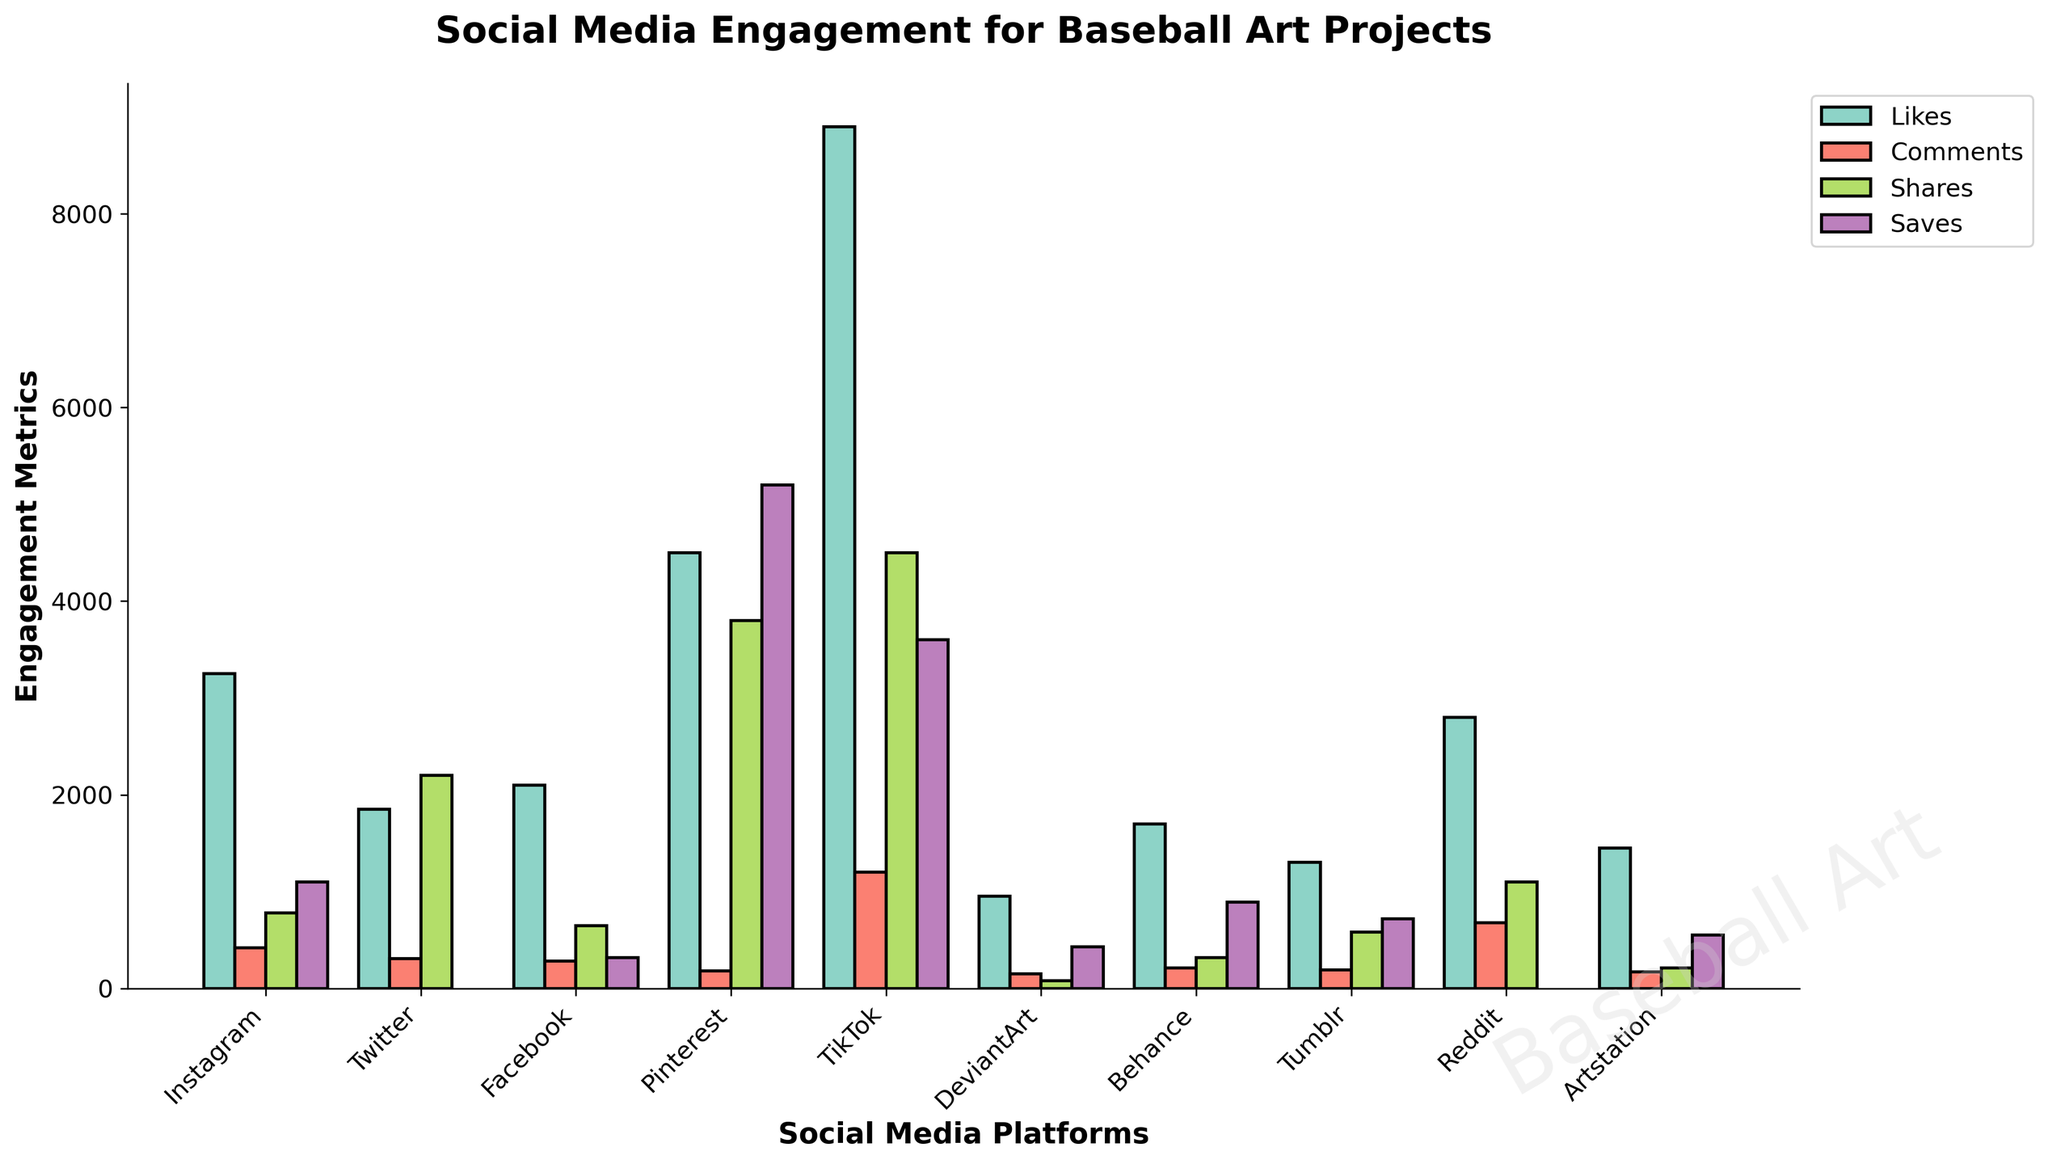Which platform has the highest number of likes? To find the platform with the highest number of likes, observe the bar heights in the "Likes" category. TikTok has the tallest bar in this category.
Answer: TikTok Which platform has the lowest comments compared to all others? Check the bar heights in the "Comments" category. Pinterest has the shortest bar.
Answer: Pinterest How many total shares are there for DeviantArt and Reddit combined? DeviantArt has 80 shares and Reddit has 1100 shares. Summing them up gives 80 + 1100.
Answer: 1180 Does any platform have fewer saves than DeviantArt? DeviantArt has 430 saves. Observe all platforms in the "Saves" category to see if there's any with fewer. No other platform has fewer saves than 430.
Answer: No Which platform has the second highest number of shares, and how does it compare to the highest one? TikTok has the highest number of shares. To find the second highest, compare the rest after TikTok. Pinterest comes second. TikTok has 4500 shares and Pinterest has 3800 shares, so 4500 - 3800 = 700.
Answer: Pinterest, 700 less What is the average number of comments across all platforms? Sum the comments for all platforms: 420 + 310 + 280 + 180 + 1200 + 150 + 210 + 190 + 680 + 170 = 3790. Divide by the number of platforms, 10. 3790 / 10 = 379.
Answer: 379 How many more saves does Pinterest have compared to Facebook? Pinterest has 5200 saves and Facebook has 320 saves. Subtract to find the difference; 5200 - 320 = 4880.
Answer: 4880 Which platform has the closest number of likes to Instagram? Instagram has 3250 likes. Facebook has 2100 likes, while Reddit has 2800 likes. Reddit is closest to Instagram.
Answer: Reddit By how much do TikTok's comments exceed Instagram's comments? TikTok has 1200 comments, and Instagram has 420 comments. Subtracting gives 1200 - 420 = 780.
Answer: 780 What is the combined number of saves for Instagram, Tumblr, and Artstation? Instagram has 1100 saves, Tumblr has 720 saves, and Artstation has 550 saves. Sum them: 1100 + 720 + 550 = 2370.
Answer: 2370 